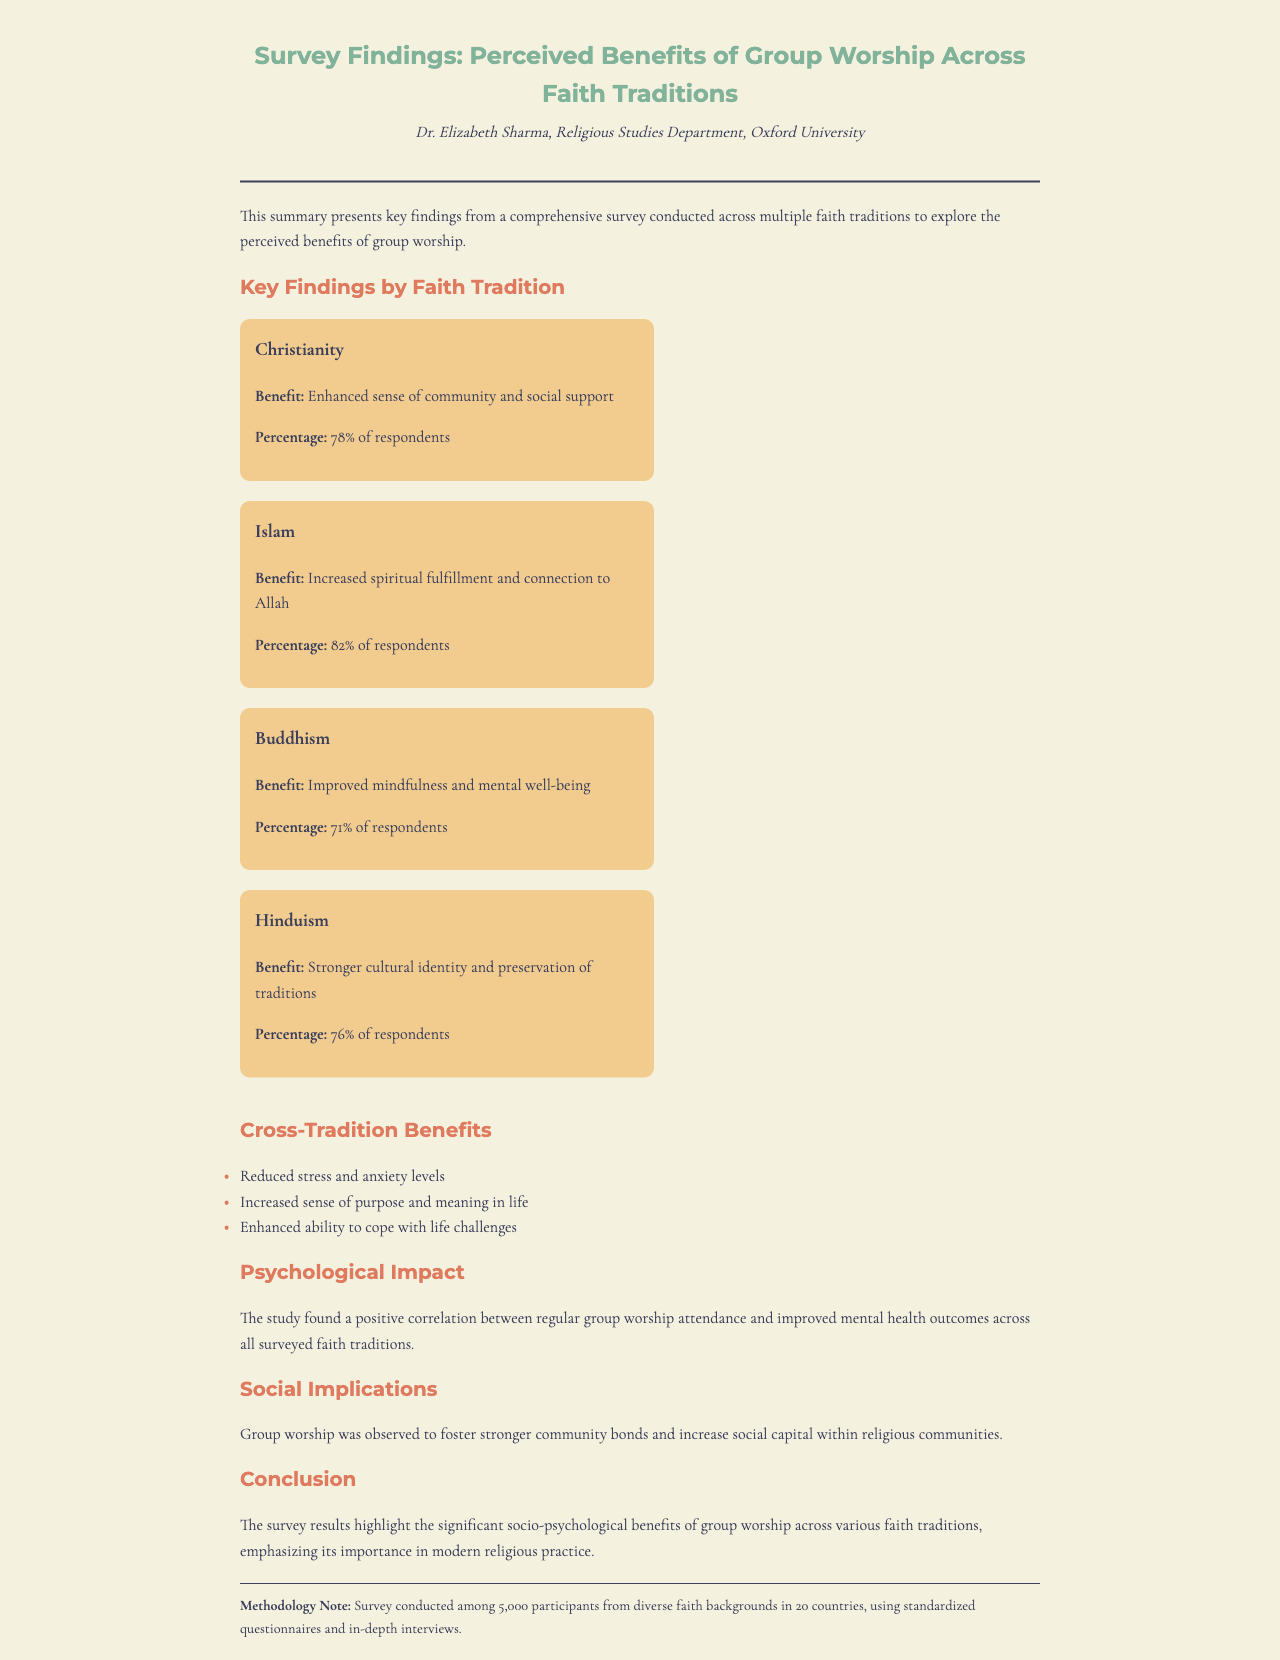What is the main purpose of the survey? The survey aimed to explore the perceived benefits of group worship across multiple faith traditions.
Answer: explore the perceived benefits of group worship How many participants were involved in the survey? The methodology note states that the survey was conducted among 5,000 participants.
Answer: 5,000 participants What percentage of respondents from Islam reported increased spiritual fulfillment? The document states that 82% of respondents from Islam indicated this benefit.
Answer: 82% What specific benefit do 78% of respondents from Christianity attribute to group worship? Christianity respondents noted an "enhanced sense of community and social support."
Answer: enhanced sense of community and social support Name one psychological impact mentioned in the findings. The document states that regular group worship attendance leads to improved mental health outcomes.
Answer: improved mental health outcomes Which faith tradition reported a benefit related to cultural identity? The document indicates that Hindus reported a "stronger cultural identity and preservation of traditions."
Answer: Hinduism What are two cross-tradition benefits listed in the survey? The document lists "reduced stress and anxiety levels" and "increased sense of purpose and meaning in life."
Answer: reduced stress and anxiety levels; increased sense of purpose and meaning in life Who is the author of the survey findings? The fax header attributes the findings to Dr. Elizabeth Sharma.
Answer: Dr. Elizabeth Sharma What social benefit does group worship encourage within communities? The survey notes that group worship fosters stronger community bonds.
Answer: stronger community bonds 